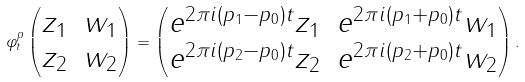Convert formula to latex. <formula><loc_0><loc_0><loc_500><loc_500>\varphi ^ { p } _ { t } \begin{pmatrix} z _ { 1 } & w _ { 1 } \\ z _ { 2 } & w _ { 2 } \end{pmatrix} = \begin{pmatrix} e ^ { 2 \pi i ( p _ { 1 } - p _ { 0 } ) t } z _ { 1 } & e ^ { 2 \pi i ( p _ { 1 } + p _ { 0 } ) t } w _ { 1 } \\ e ^ { 2 \pi i ( p _ { 2 } - p _ { 0 } ) t } z _ { 2 } & e ^ { 2 \pi i ( p _ { 2 } + p _ { 0 } ) t } w _ { 2 } \end{pmatrix} .</formula> 